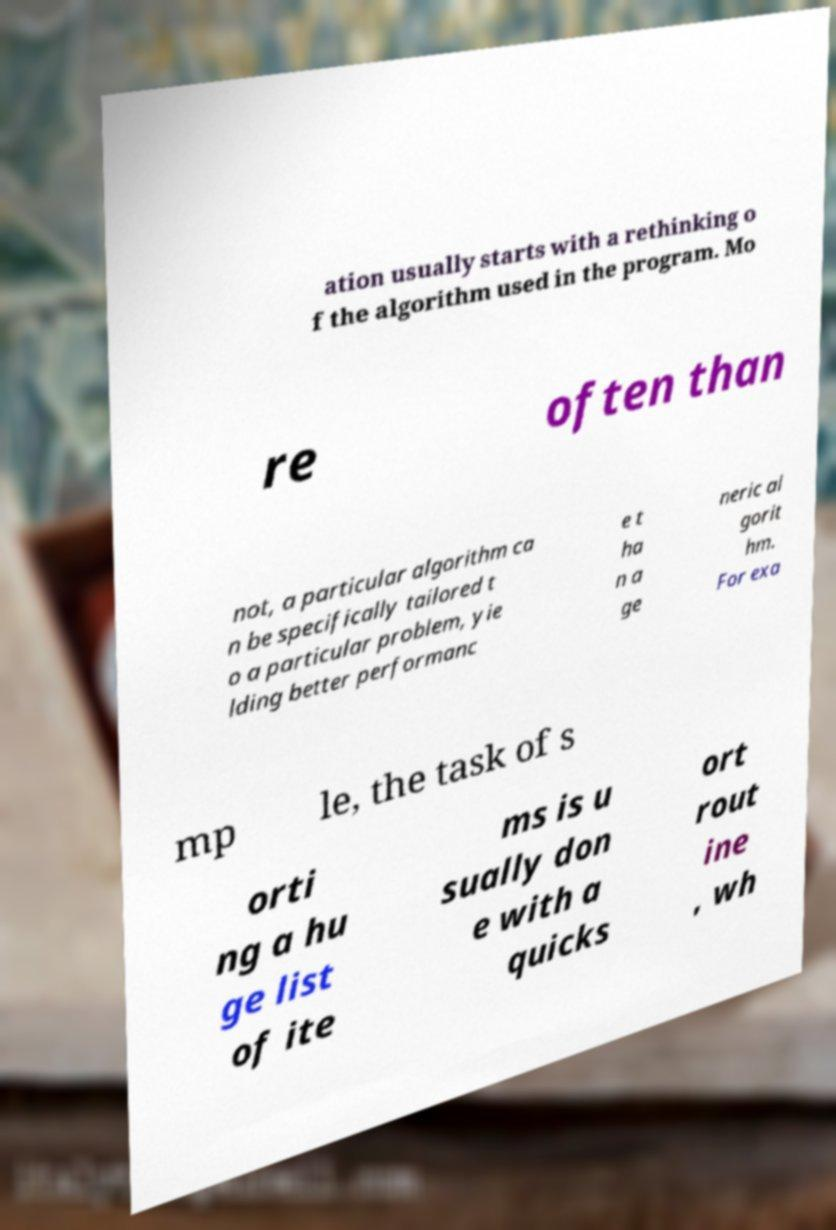I need the written content from this picture converted into text. Can you do that? ation usually starts with a rethinking o f the algorithm used in the program. Mo re often than not, a particular algorithm ca n be specifically tailored t o a particular problem, yie lding better performanc e t ha n a ge neric al gorit hm. For exa mp le, the task of s orti ng a hu ge list of ite ms is u sually don e with a quicks ort rout ine , wh 